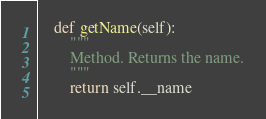<code> <loc_0><loc_0><loc_500><loc_500><_Python_>	def getName(self):
		"""
		Method. Returns the name.
		"""
		return self.__name
</code> 